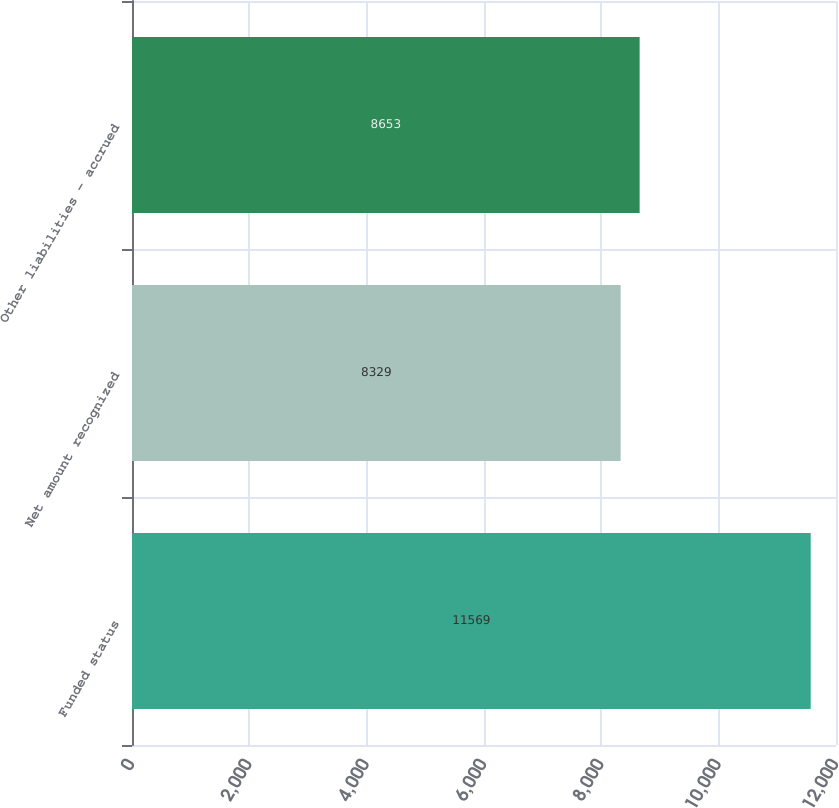<chart> <loc_0><loc_0><loc_500><loc_500><bar_chart><fcel>Funded status<fcel>Net amount recognized<fcel>Other liabilities - accrued<nl><fcel>11569<fcel>8329<fcel>8653<nl></chart> 